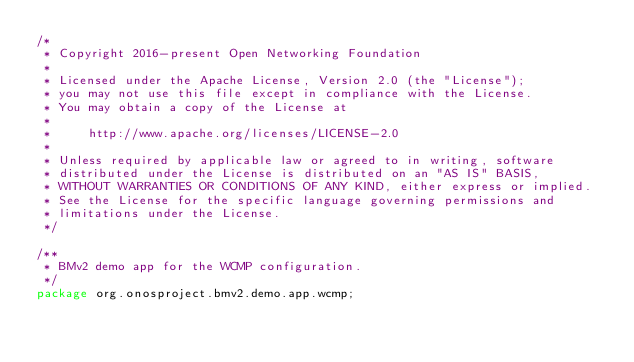Convert code to text. <code><loc_0><loc_0><loc_500><loc_500><_Java_>/*
 * Copyright 2016-present Open Networking Foundation
 *
 * Licensed under the Apache License, Version 2.0 (the "License");
 * you may not use this file except in compliance with the License.
 * You may obtain a copy of the License at
 *
 *     http://www.apache.org/licenses/LICENSE-2.0
 *
 * Unless required by applicable law or agreed to in writing, software
 * distributed under the License is distributed on an "AS IS" BASIS,
 * WITHOUT WARRANTIES OR CONDITIONS OF ANY KIND, either express or implied.
 * See the License for the specific language governing permissions and
 * limitations under the License.
 */

/**
 * BMv2 demo app for the WCMP configuration.
 */
package org.onosproject.bmv2.demo.app.wcmp;</code> 